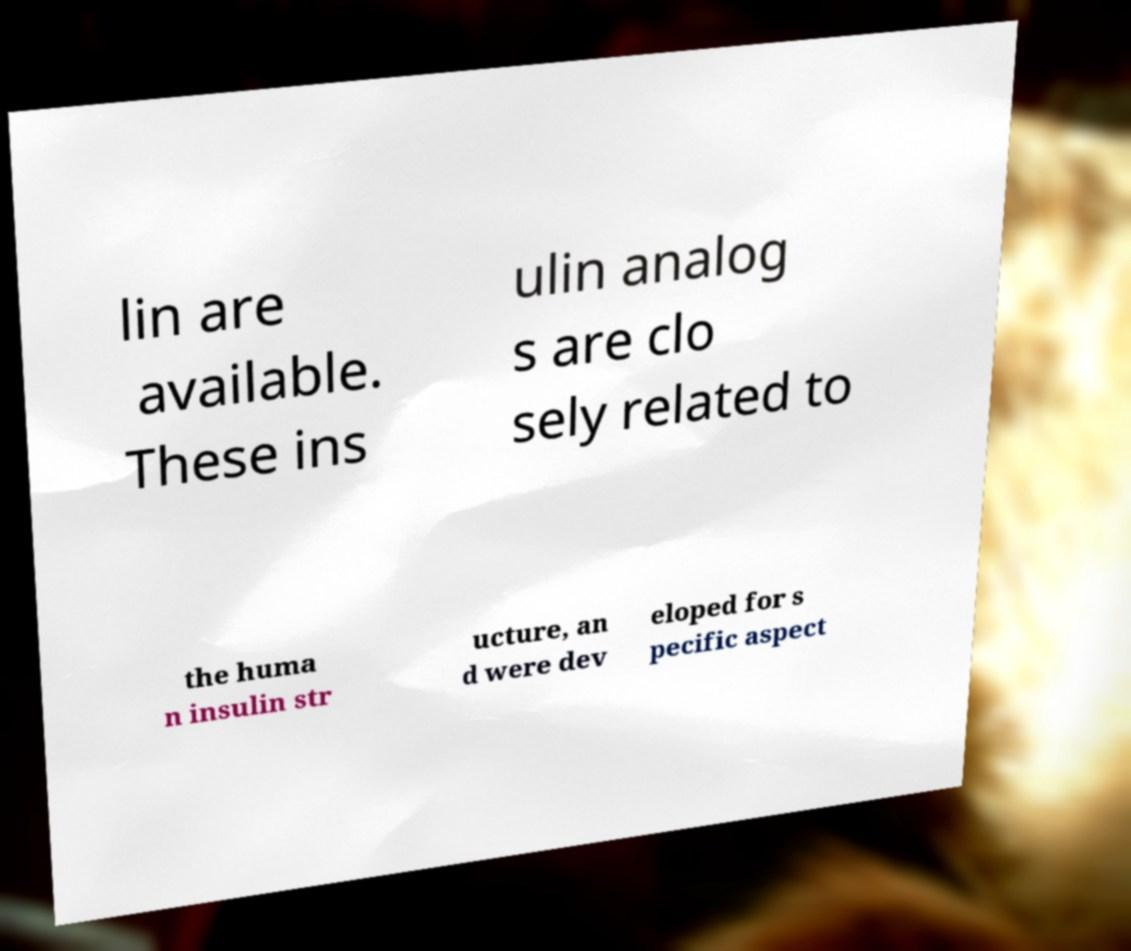Can you read and provide the text displayed in the image?This photo seems to have some interesting text. Can you extract and type it out for me? lin are available. These ins ulin analog s are clo sely related to the huma n insulin str ucture, an d were dev eloped for s pecific aspect 